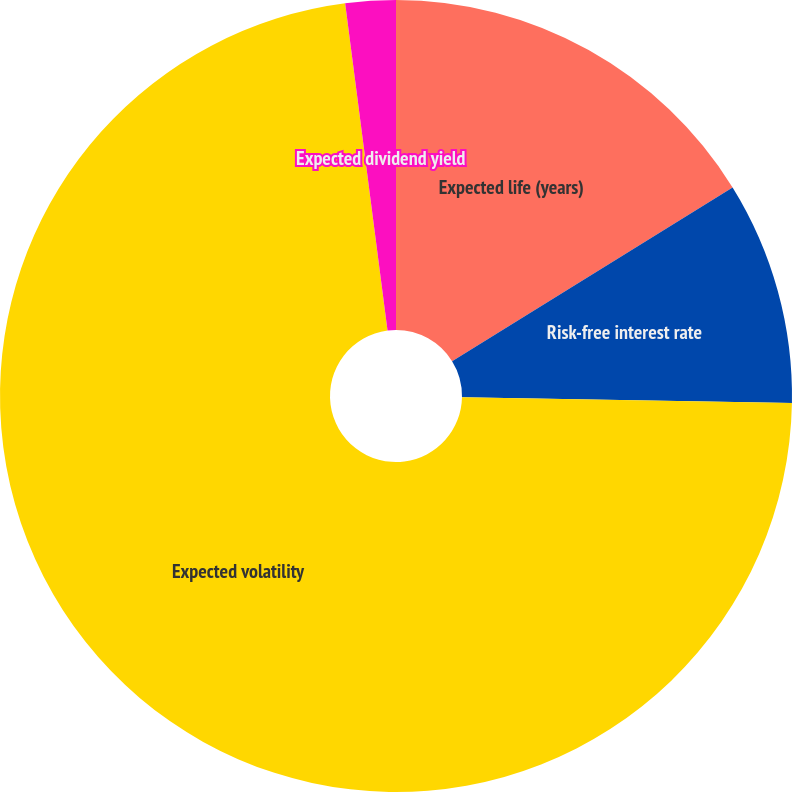<chart> <loc_0><loc_0><loc_500><loc_500><pie_chart><fcel>Expected life (years)<fcel>Risk-free interest rate<fcel>Expected volatility<fcel>Expected dividend yield<nl><fcel>16.17%<fcel>9.11%<fcel>72.67%<fcel>2.05%<nl></chart> 